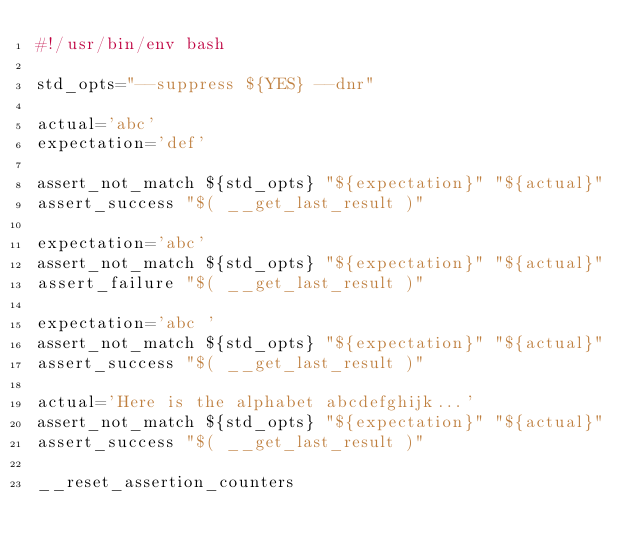Convert code to text. <code><loc_0><loc_0><loc_500><loc_500><_Bash_>#!/usr/bin/env bash

std_opts="--suppress ${YES} --dnr"

actual='abc'
expectation='def'

assert_not_match ${std_opts} "${expectation}" "${actual}"
assert_success "$( __get_last_result )"

expectation='abc'
assert_not_match ${std_opts} "${expectation}" "${actual}"
assert_failure "$( __get_last_result )"

expectation='abc '
assert_not_match ${std_opts} "${expectation}" "${actual}"
assert_success "$( __get_last_result )"

actual='Here is the alphabet abcdefghijk...'
assert_not_match ${std_opts} "${expectation}" "${actual}"
assert_success "$( __get_last_result )"

__reset_assertion_counters
</code> 